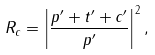<formula> <loc_0><loc_0><loc_500><loc_500>R _ { c } = \left | \frac { p ^ { \prime } + t ^ { \prime } + c ^ { \prime } } { p ^ { \prime } } \right | ^ { 2 } ,</formula> 